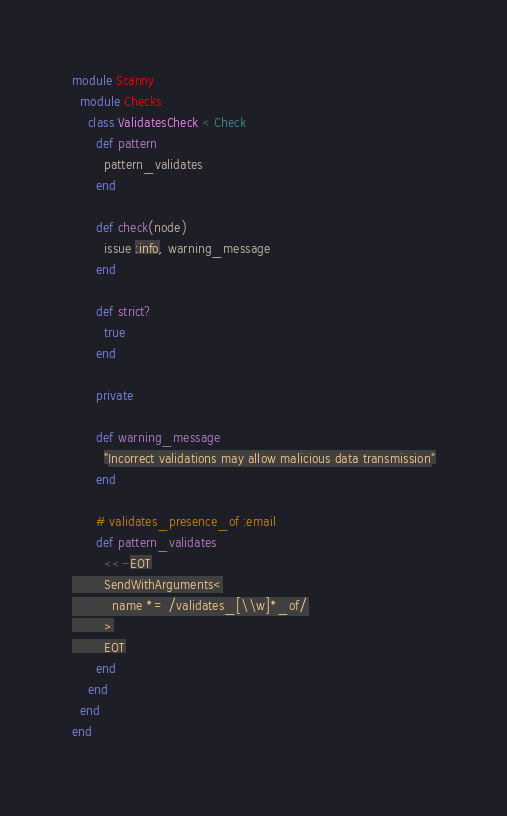Convert code to text. <code><loc_0><loc_0><loc_500><loc_500><_Ruby_>module Scanny
  module Checks
    class ValidatesCheck < Check
      def pattern
        pattern_validates
      end

      def check(node)
        issue :info, warning_message
      end

      def strict?
        true
      end

      private

      def warning_message
        "Incorrect validations may allow malicious data transmission"
      end

      # validates_presence_of :email
      def pattern_validates
        <<-EOT
        SendWithArguments<
          name *= /validates_[\\w]*_of/
        >
        EOT
      end
    end
  end
end</code> 